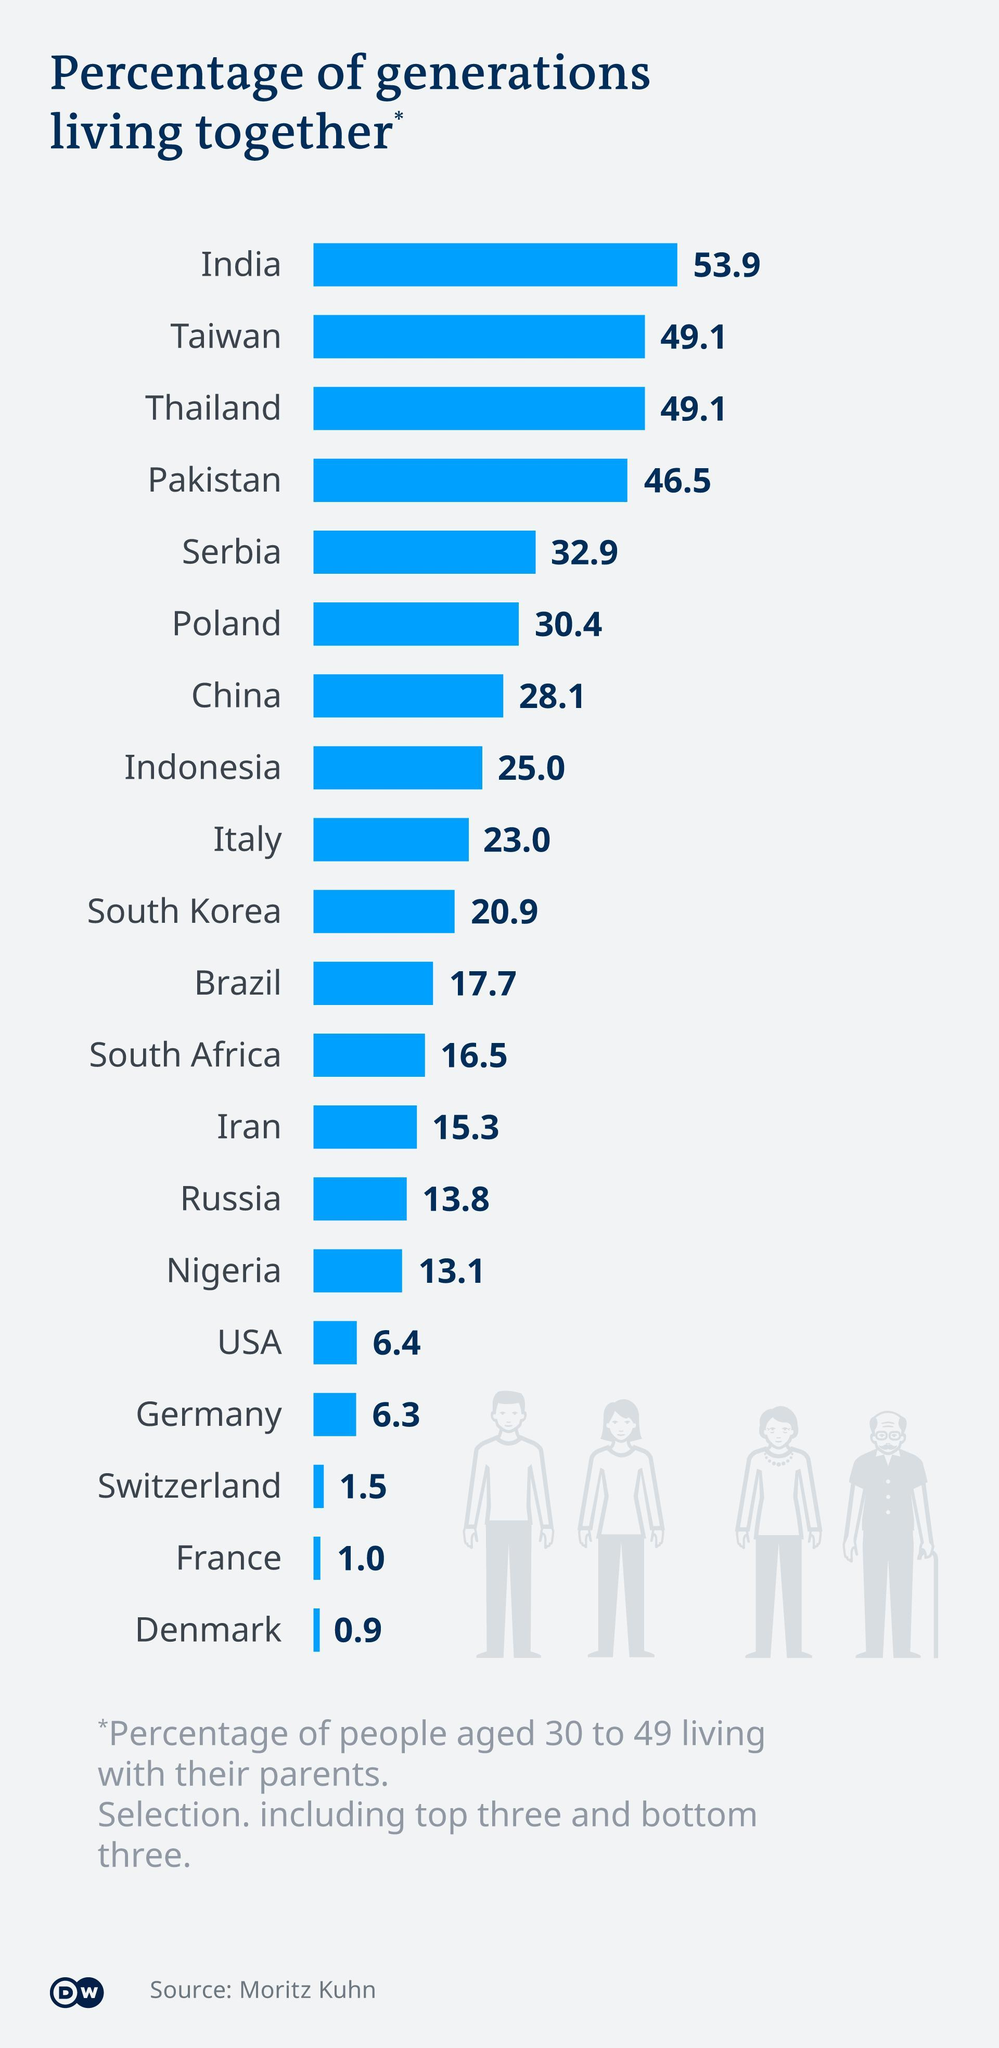Which countries have 49.1% of generations living together?
Answer the question with a short phrase. Taiwan, Thailand How many countries are included in the survey? 20 How many people are shown in the infographic? 4 Which country has more than 50% of generations living together? India Which countries have less than 2% of generations of people living together? Switzerland, France, Denmark 